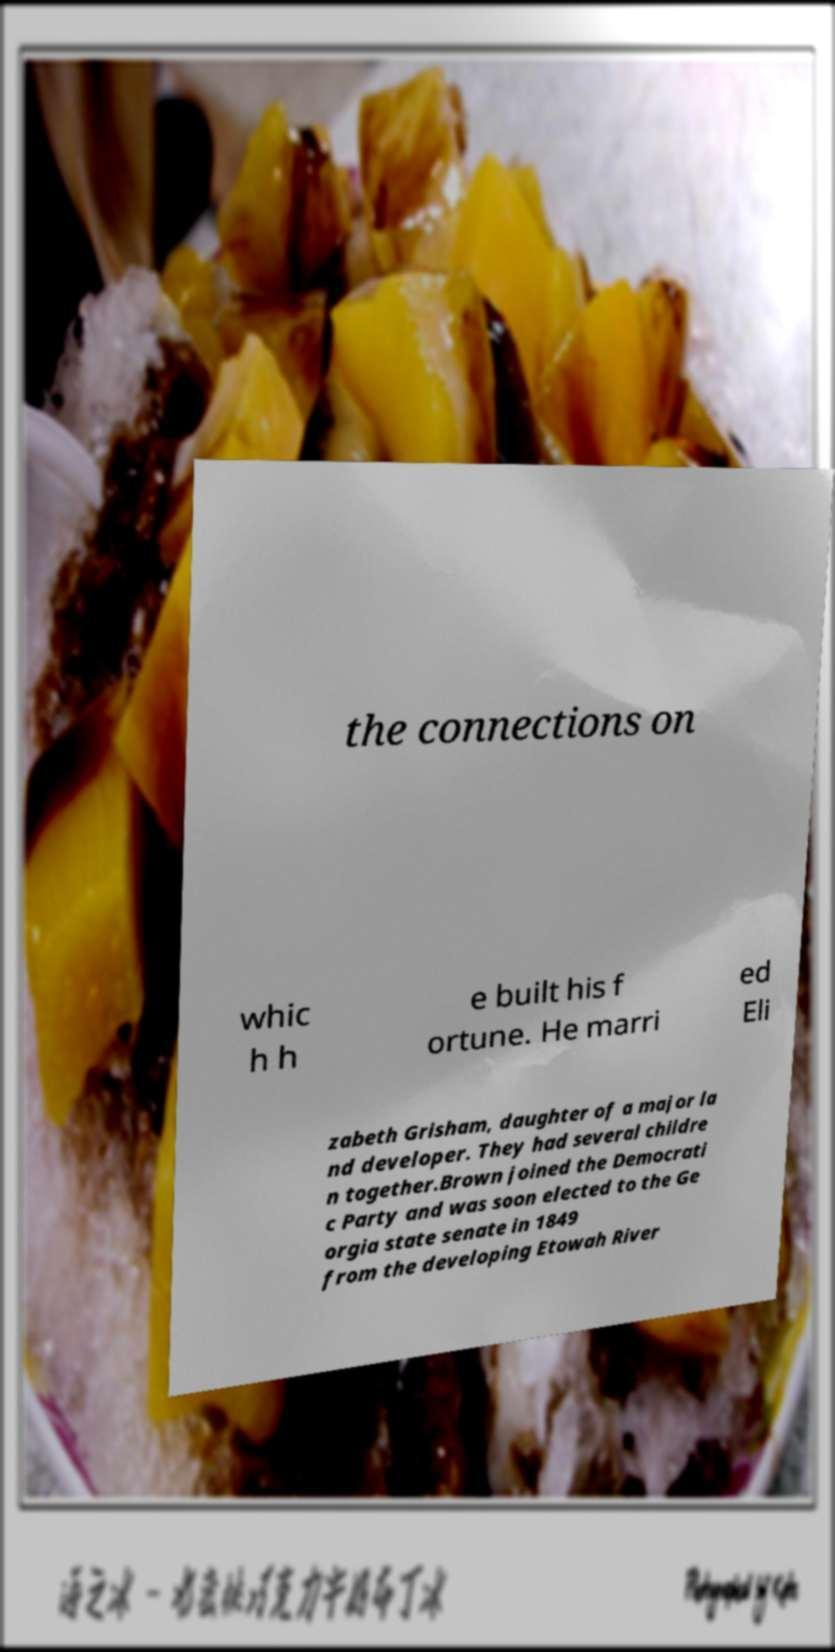Can you read and provide the text displayed in the image?This photo seems to have some interesting text. Can you extract and type it out for me? the connections on whic h h e built his f ortune. He marri ed Eli zabeth Grisham, daughter of a major la nd developer. They had several childre n together.Brown joined the Democrati c Party and was soon elected to the Ge orgia state senate in 1849 from the developing Etowah River 